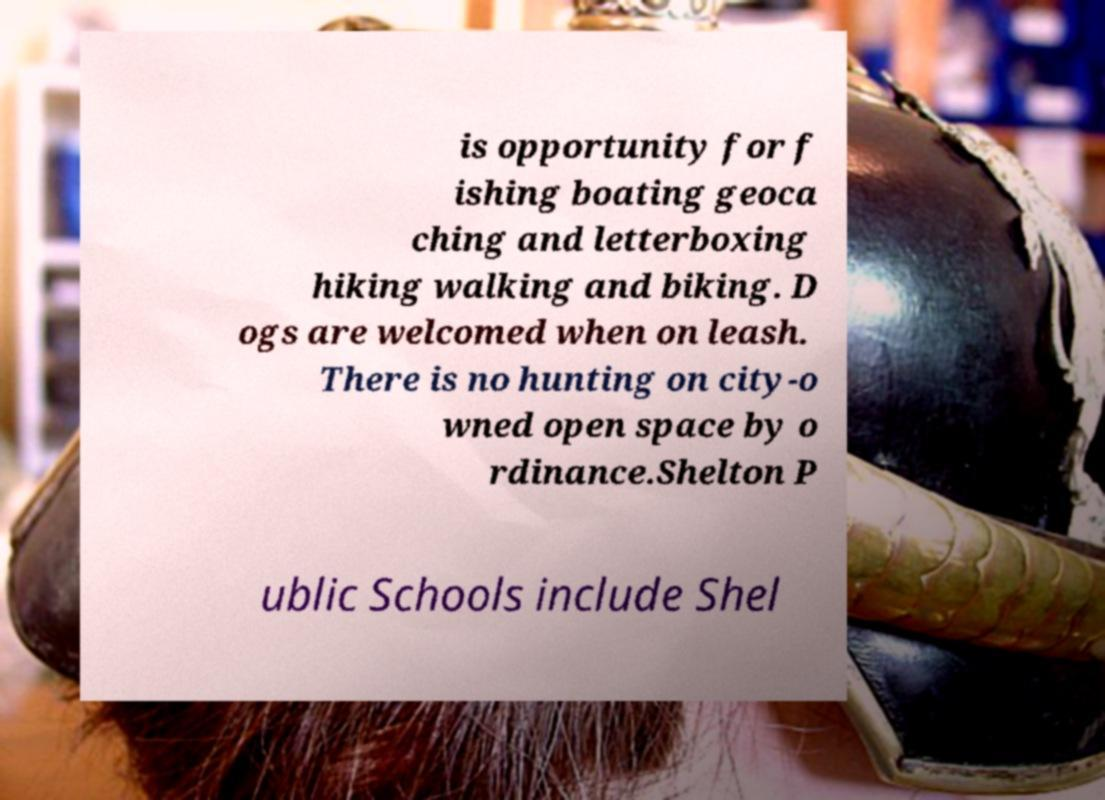Can you read and provide the text displayed in the image?This photo seems to have some interesting text. Can you extract and type it out for me? is opportunity for f ishing boating geoca ching and letterboxing hiking walking and biking. D ogs are welcomed when on leash. There is no hunting on city-o wned open space by o rdinance.Shelton P ublic Schools include Shel 